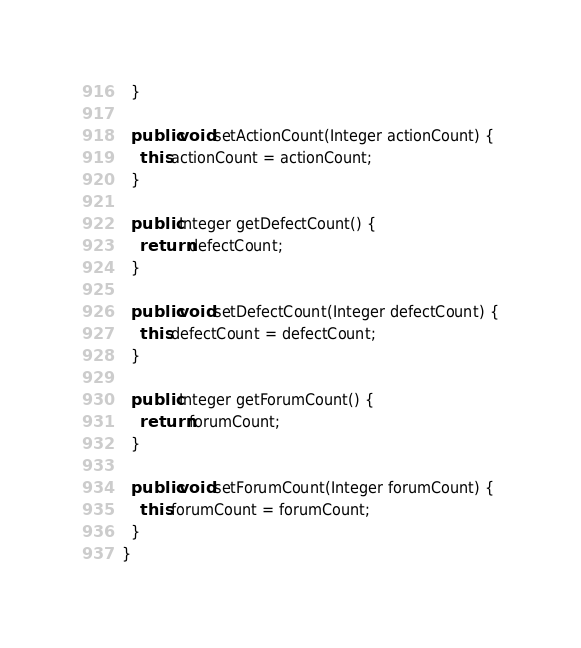<code> <loc_0><loc_0><loc_500><loc_500><_Java_>  }

  public void setActionCount(Integer actionCount) {
    this.actionCount = actionCount;
  }

  public Integer getDefectCount() {
    return defectCount;
  }

  public void setDefectCount(Integer defectCount) {
    this.defectCount = defectCount;
  }

  public Integer getForumCount() {
    return forumCount;
  }

  public void setForumCount(Integer forumCount) {
    this.forumCount = forumCount;
  }
}
</code> 